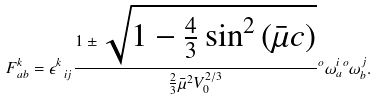Convert formula to latex. <formula><loc_0><loc_0><loc_500><loc_500>F _ { a b } ^ { k } = \epsilon ^ { k } _ { \ i j } \frac { 1 \pm \sqrt { 1 - \frac { 4 } { 3 } \sin ^ { 2 } \left ( \bar { \mu } c \right ) } } { \frac { 2 } { 3 } \bar { \mu } ^ { 2 } V _ { 0 } ^ { 2 / 3 } } { ^ { o } \omega ^ { i } _ { a } } { ^ { o } \omega ^ { j } _ { b } } .</formula> 